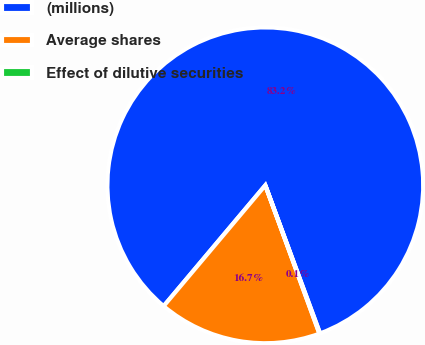Convert chart. <chart><loc_0><loc_0><loc_500><loc_500><pie_chart><fcel>(millions)<fcel>Average shares<fcel>Effect of dilutive securities<nl><fcel>83.23%<fcel>16.7%<fcel>0.07%<nl></chart> 